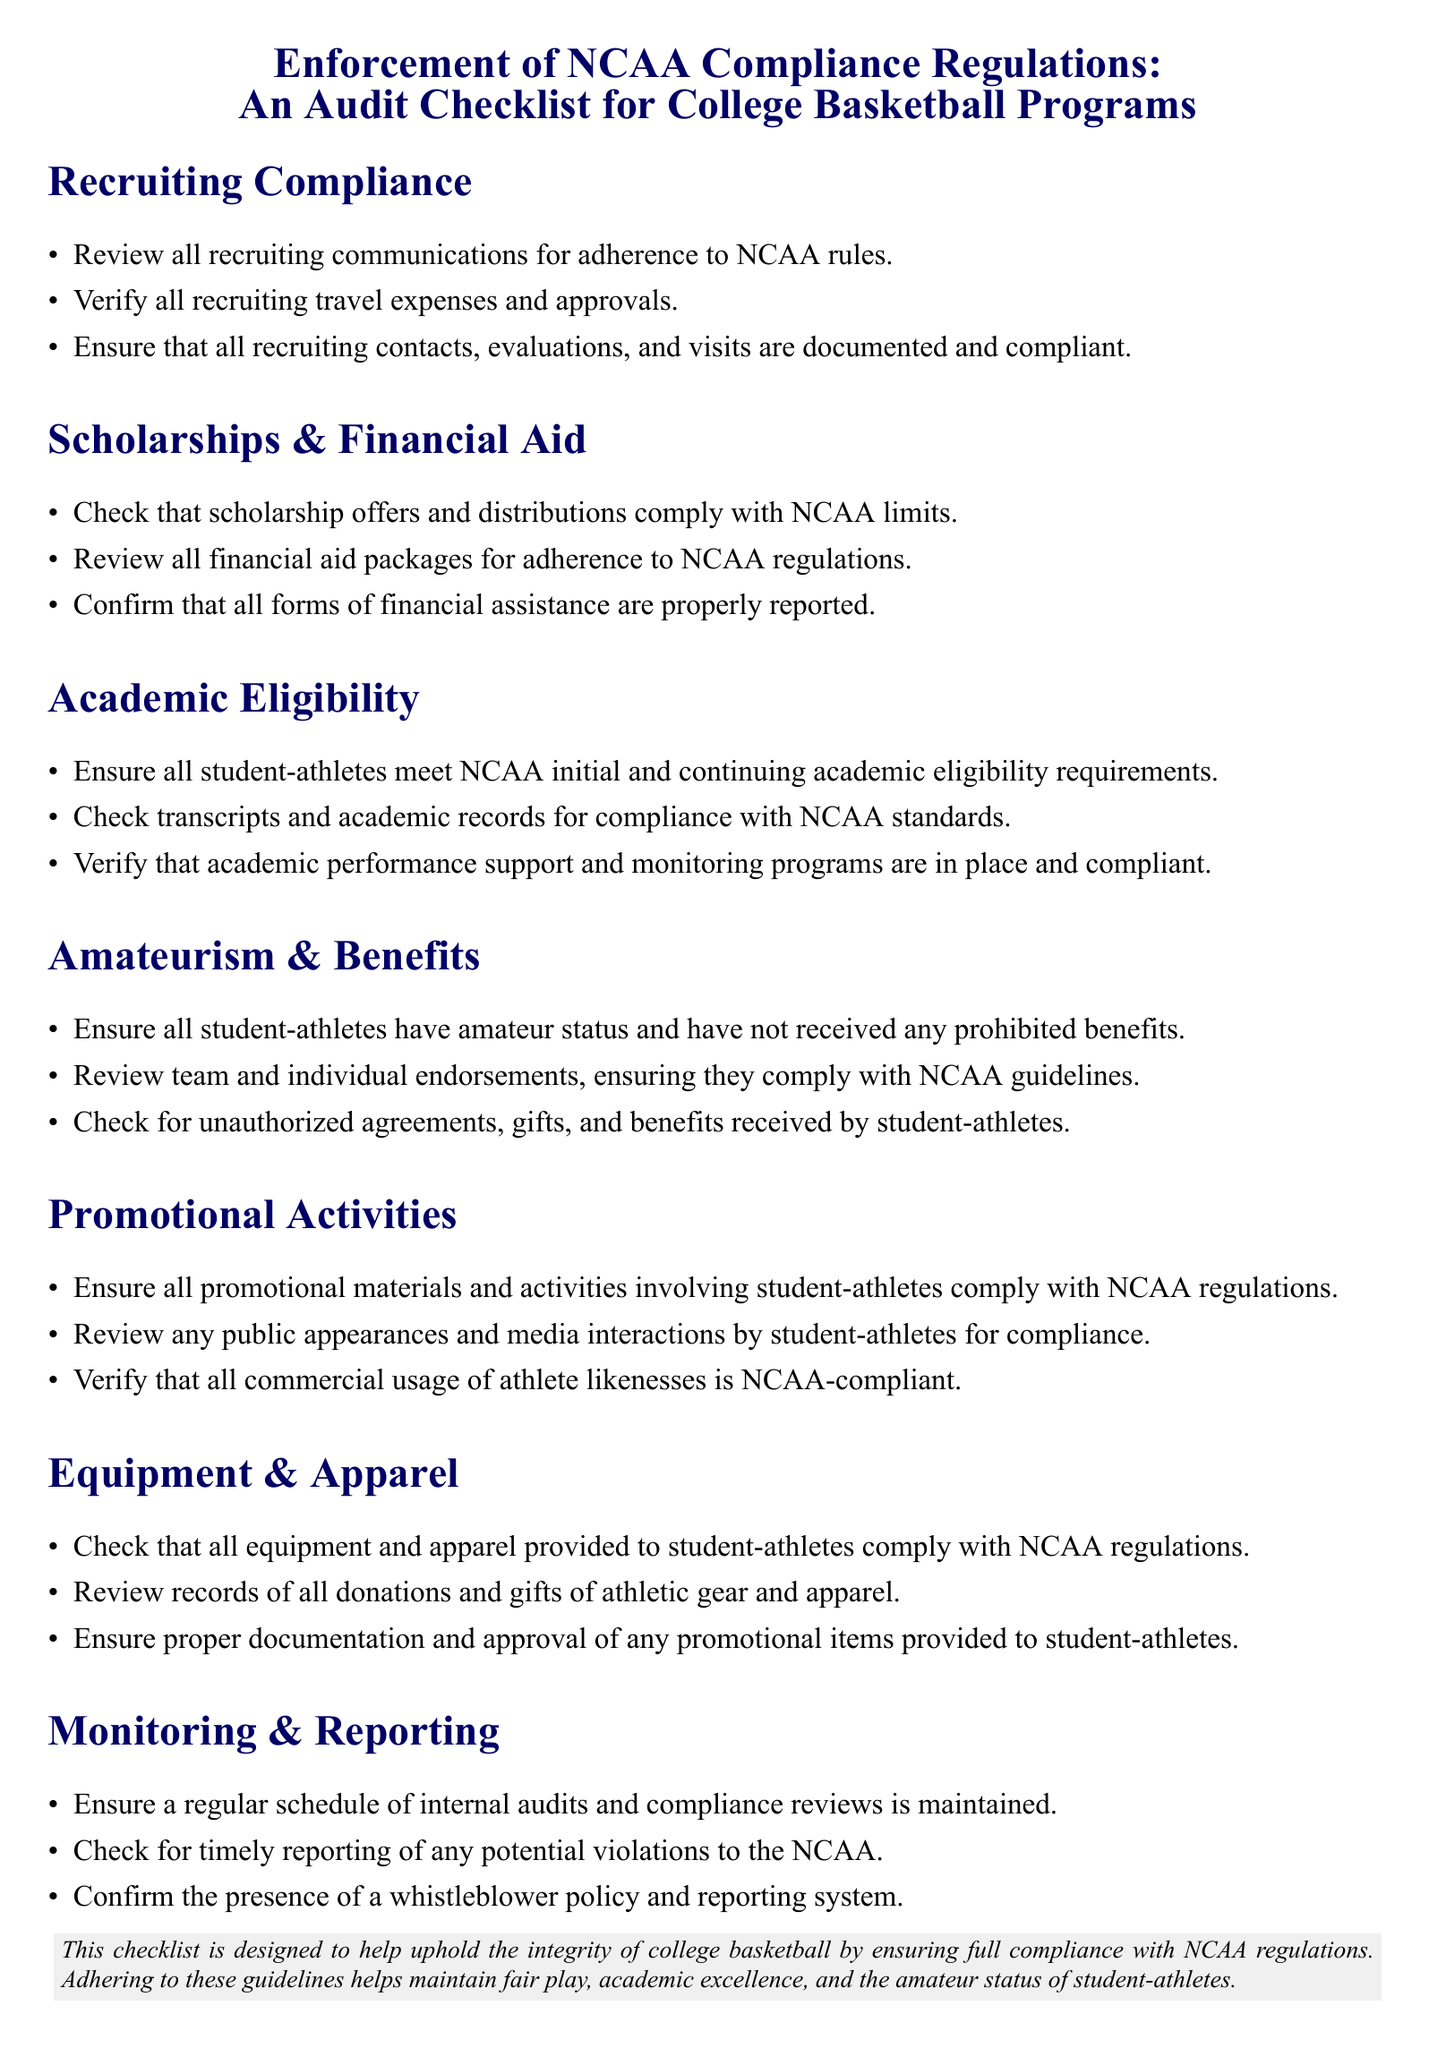what is the main title of the document? The main title is presented prominently at the top of the document, encapsulating its focus on enforcing compliance regulations in college basketball.
Answer: Enforcement of NCAA Compliance Regulations: An Audit Checklist for College Basketball Programs how many sections are included in the checklist? The document enumerates the different compliance areas through section headings, which denote the count of unique sections.
Answer: 7 what is the color of the headings in the checklist? The color of the section headings is specified in the document, providing a visual consistency throughout.
Answer: Dark blue what type of policy is mentioned under the Monitoring & Reporting section? This policy is essential for maintaining integrity and provides a system for reporting compliance issues, crucial in audits.
Answer: Whistleblower policy how many items are listed under the Amateurism & Benefits section? The count of items in this section indicates specific compliance checks related to amateur status and benefits for student-athletes.
Answer: 3 what is the primary focus of the Promotional Activities section? The section emphasizes compliance related to promotional engagements involving student-athletes, ensuring adherence to regulations.
Answer: Compliance with NCAA regulations which area requires verification of financial aid packages? This area is crucial for ensuring that financial assistance conforms to established NCAA standards.
Answer: Scholarships & Financial Aid 